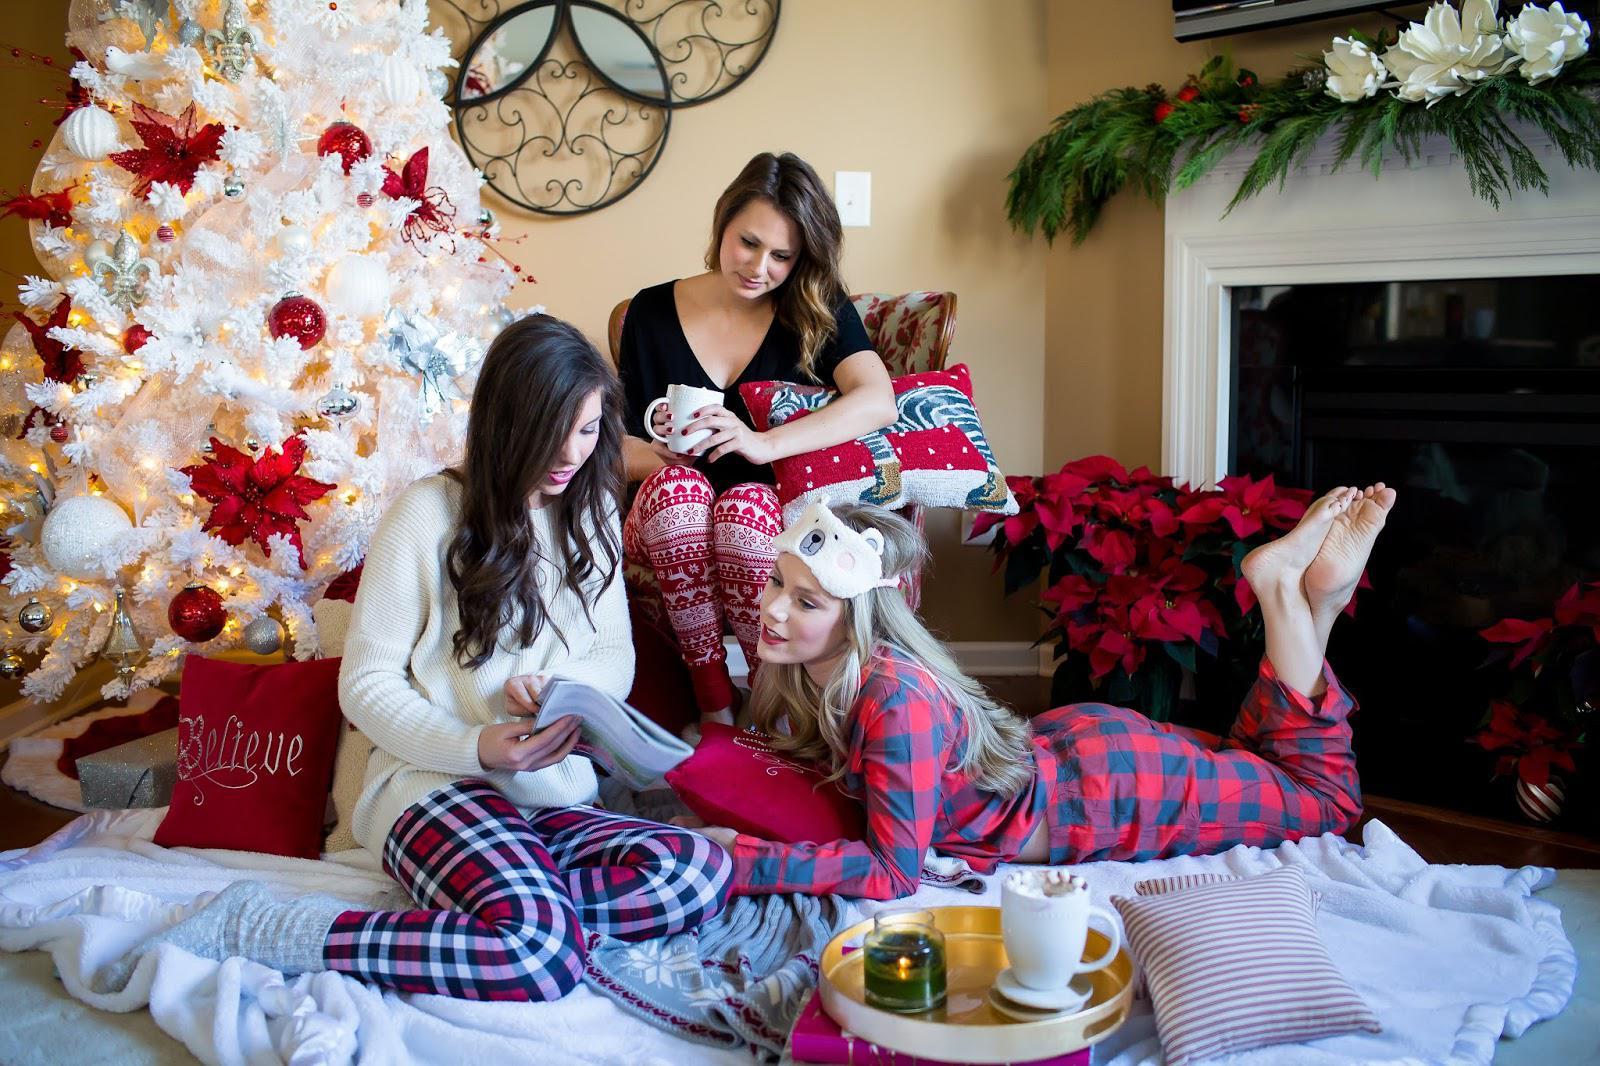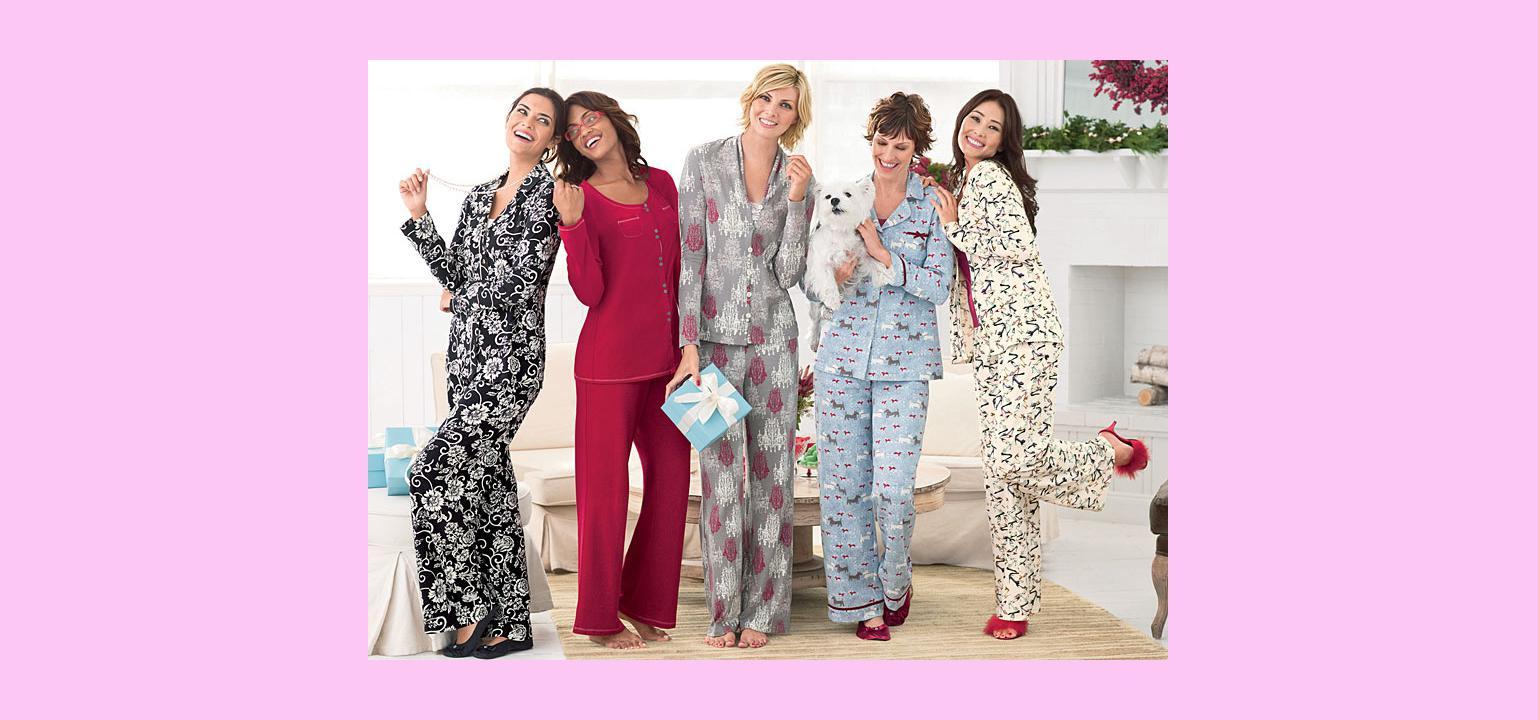The first image is the image on the left, the second image is the image on the right. Given the left and right images, does the statement "An image shows a woman in printed pj pants sitting in front of a small pink Christmas tree." hold true? Answer yes or no. No. 